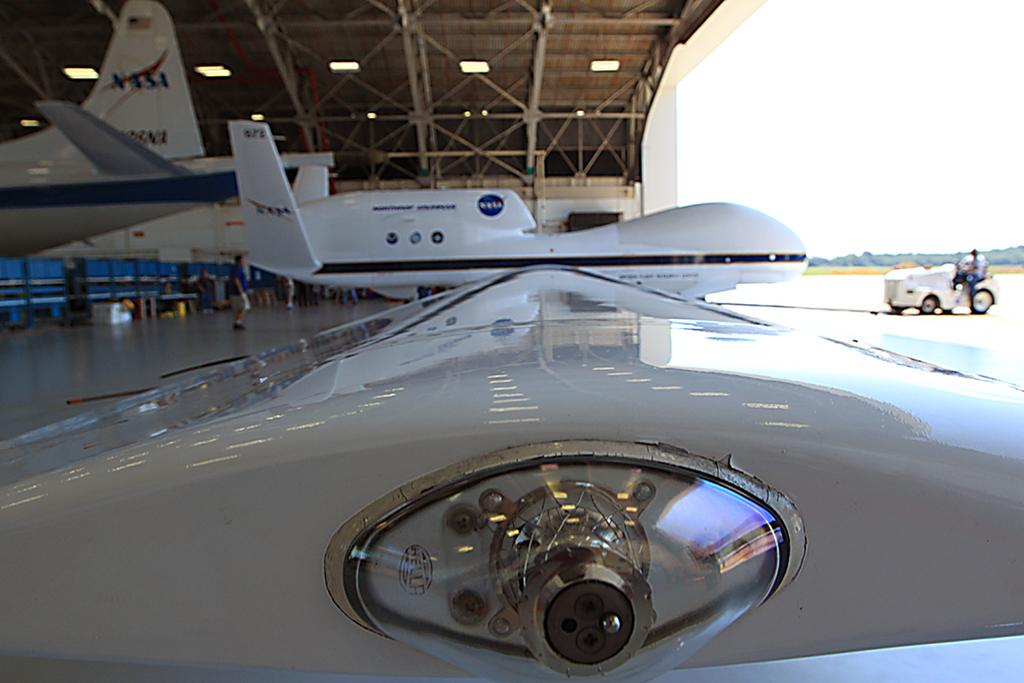<image>
Write a terse but informative summary of the picture. A hangar with several airplanes that are for NASA. 